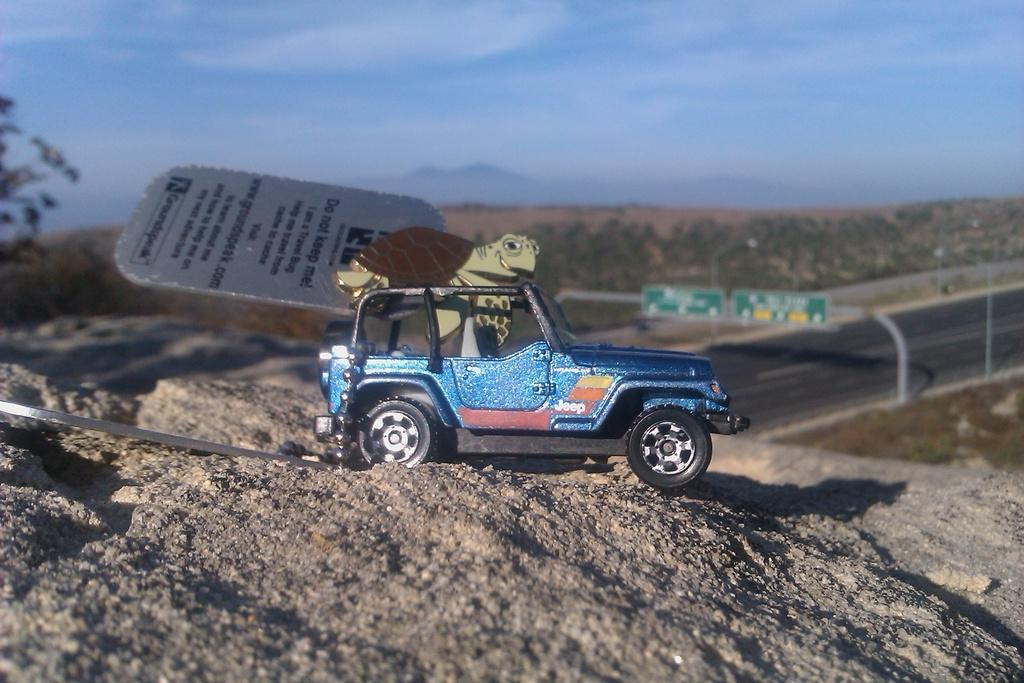What is the main subject of the image? The main subject of the image is a toy jeep on a stone. What decoration is on the toy jeep? The toy jeep has a turtle sticker above it. What can be seen in the background of the image? There is a highway road in the background of the image. What type of vegetation is present on either side of the highway road? Plants are present on either side of the highway road. What is visible in the sky in the image? The sky is visible in the image, and clouds are present. Where is the store located in the image? There is no store present in the image. What type of hole can be seen in the image? There is no hole present in the image. 